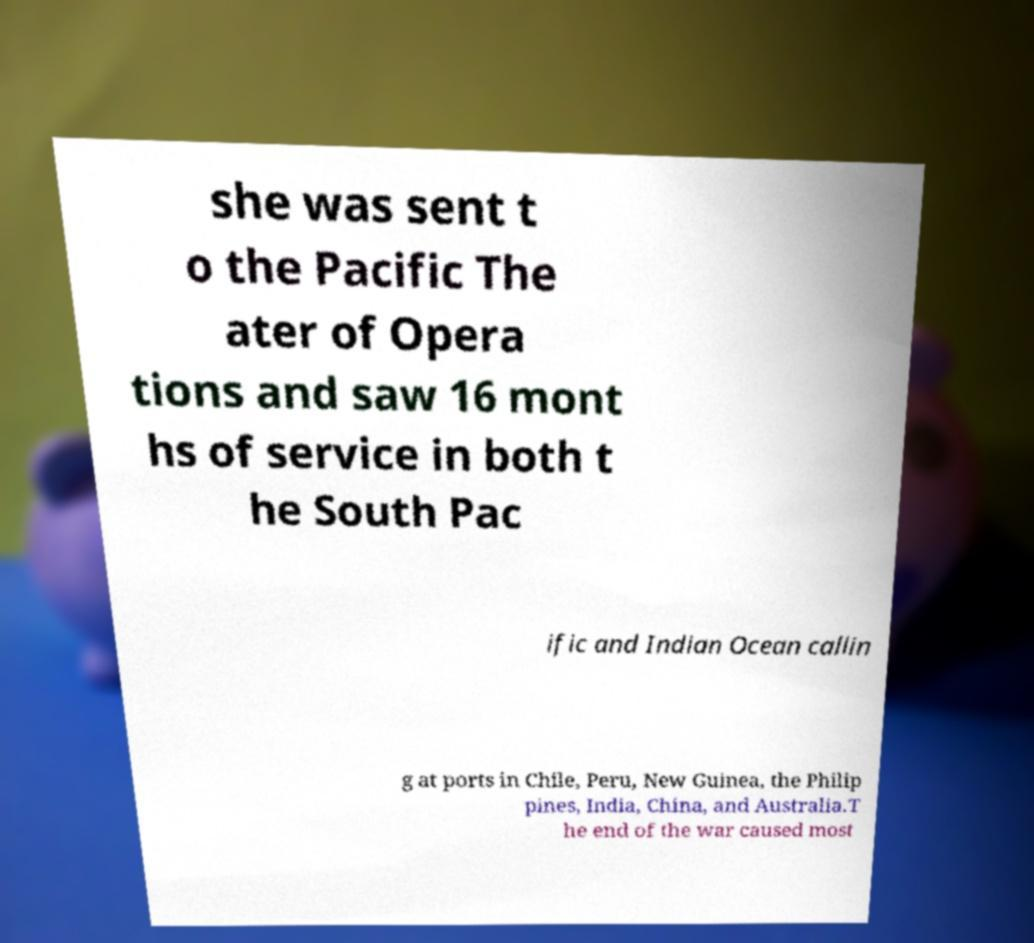Could you assist in decoding the text presented in this image and type it out clearly? she was sent t o the Pacific The ater of Opera tions and saw 16 mont hs of service in both t he South Pac ific and Indian Ocean callin g at ports in Chile, Peru, New Guinea, the Philip pines, India, China, and Australia.T he end of the war caused most 